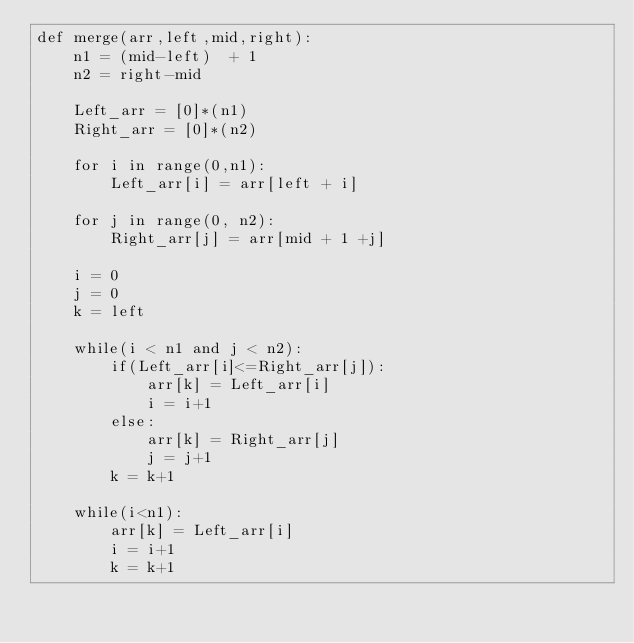Convert code to text. <code><loc_0><loc_0><loc_500><loc_500><_Python_>def merge(arr,left,mid,right):
    n1 = (mid-left)  + 1
    n2 = right-mid

    Left_arr = [0]*(n1)
    Right_arr = [0]*(n2)

    for i in range(0,n1):
        Left_arr[i] = arr[left + i]

    for j in range(0, n2):
        Right_arr[j] = arr[mid + 1 +j]

    i = 0
    j = 0
    k = left

    while(i < n1 and j < n2):
        if(Left_arr[i]<=Right_arr[j]):
            arr[k] = Left_arr[i]
            i = i+1
        else:
            arr[k] = Right_arr[j]
            j = j+1
        k = k+1

    while(i<n1):
        arr[k] = Left_arr[i]
        i = i+1
        k = k+1
</code> 